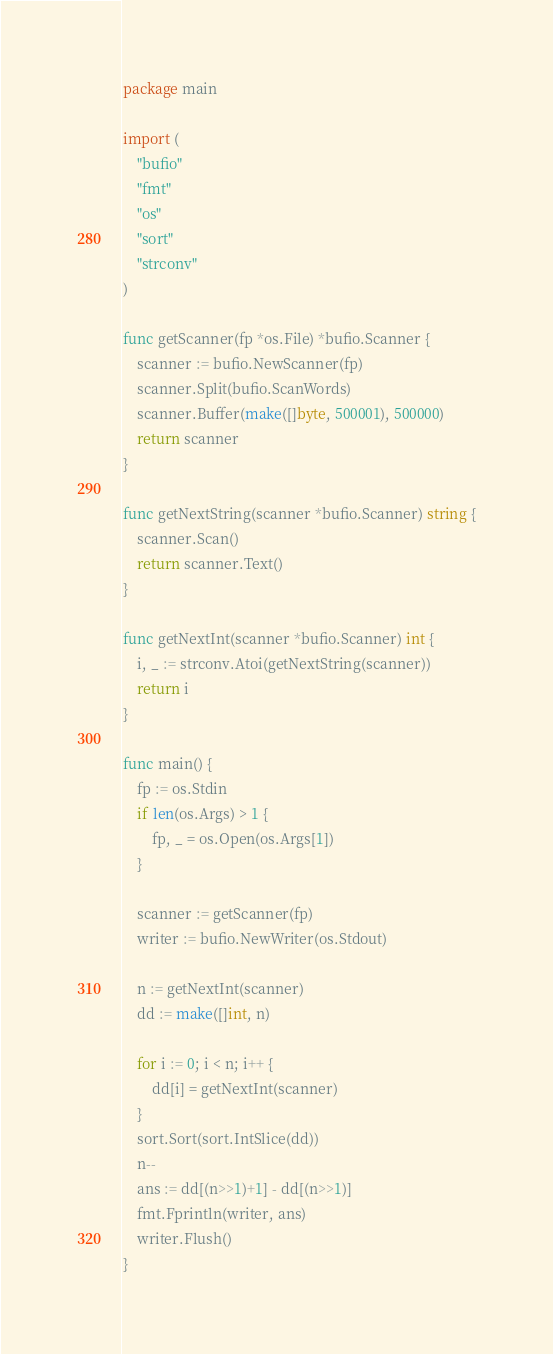<code> <loc_0><loc_0><loc_500><loc_500><_Go_>package main

import (
	"bufio"
	"fmt"
	"os"
	"sort"
	"strconv"
)

func getScanner(fp *os.File) *bufio.Scanner {
	scanner := bufio.NewScanner(fp)
	scanner.Split(bufio.ScanWords)
	scanner.Buffer(make([]byte, 500001), 500000)
	return scanner
}

func getNextString(scanner *bufio.Scanner) string {
	scanner.Scan()
	return scanner.Text()
}

func getNextInt(scanner *bufio.Scanner) int {
	i, _ := strconv.Atoi(getNextString(scanner))
	return i
}

func main() {
	fp := os.Stdin
	if len(os.Args) > 1 {
		fp, _ = os.Open(os.Args[1])
	}

	scanner := getScanner(fp)
	writer := bufio.NewWriter(os.Stdout)

	n := getNextInt(scanner)
	dd := make([]int, n)

	for i := 0; i < n; i++ {
		dd[i] = getNextInt(scanner)
	}
	sort.Sort(sort.IntSlice(dd))
	n--
	ans := dd[(n>>1)+1] - dd[(n>>1)]
	fmt.Fprintln(writer, ans)
	writer.Flush()
}
</code> 